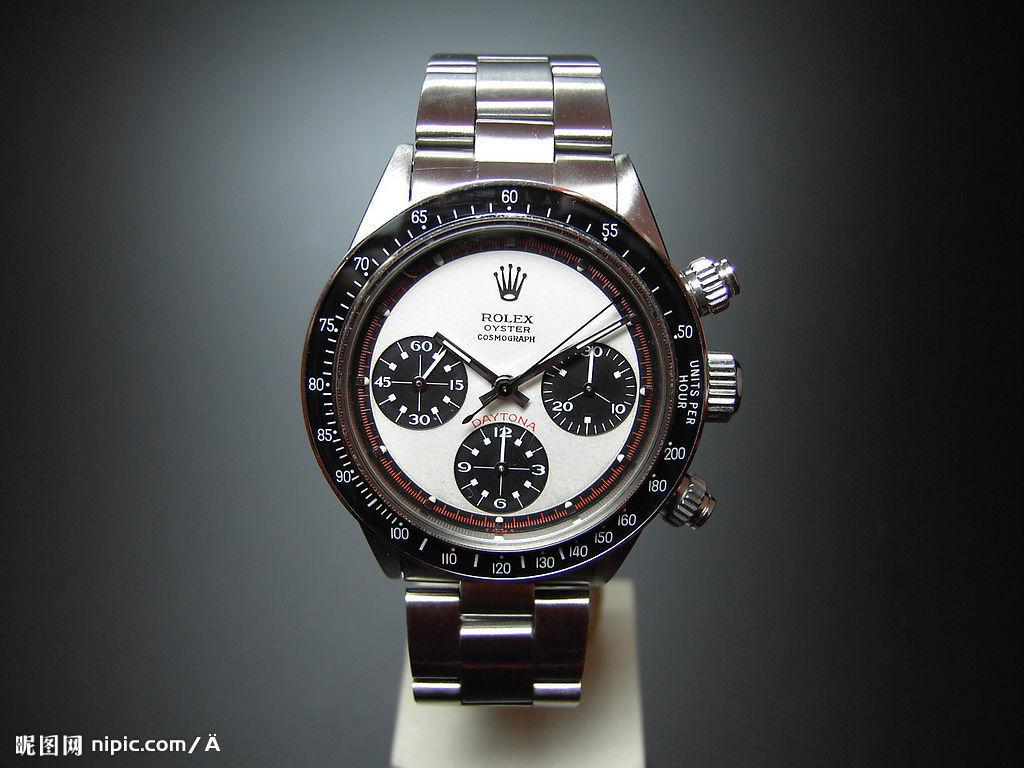<image>
Present a compact description of the photo's key features. a Rolex Oyster Cosmograph watch on display somewhere 